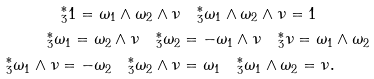<formula> <loc_0><loc_0><loc_500><loc_500>^ { * } _ { 3 } 1 = \omega _ { 1 } \wedge \omega _ { 2 } \wedge \nu & \quad ^ { * } _ { 3 } \omega _ { 1 } \wedge \omega _ { 2 } \wedge \nu = 1 \\ ^ { * } _ { 3 } \omega _ { 1 } = \omega _ { 2 } \wedge \nu \quad ^ { * } _ { 3 } \omega _ { 2 } & = - \omega _ { 1 } \wedge \nu \quad ^ { * } _ { 3 } \nu = \omega _ { 1 } \wedge \omega _ { 2 } \\ ^ { * } _ { 3 } \omega _ { 1 } \wedge \nu = - \omega _ { 2 } \quad ^ { * } _ { 3 } \omega _ { 2 } \wedge \nu & = \omega _ { 1 } \quad ^ { * } _ { 3 } \omega _ { 1 } \wedge \omega _ { 2 } = \nu .</formula> 